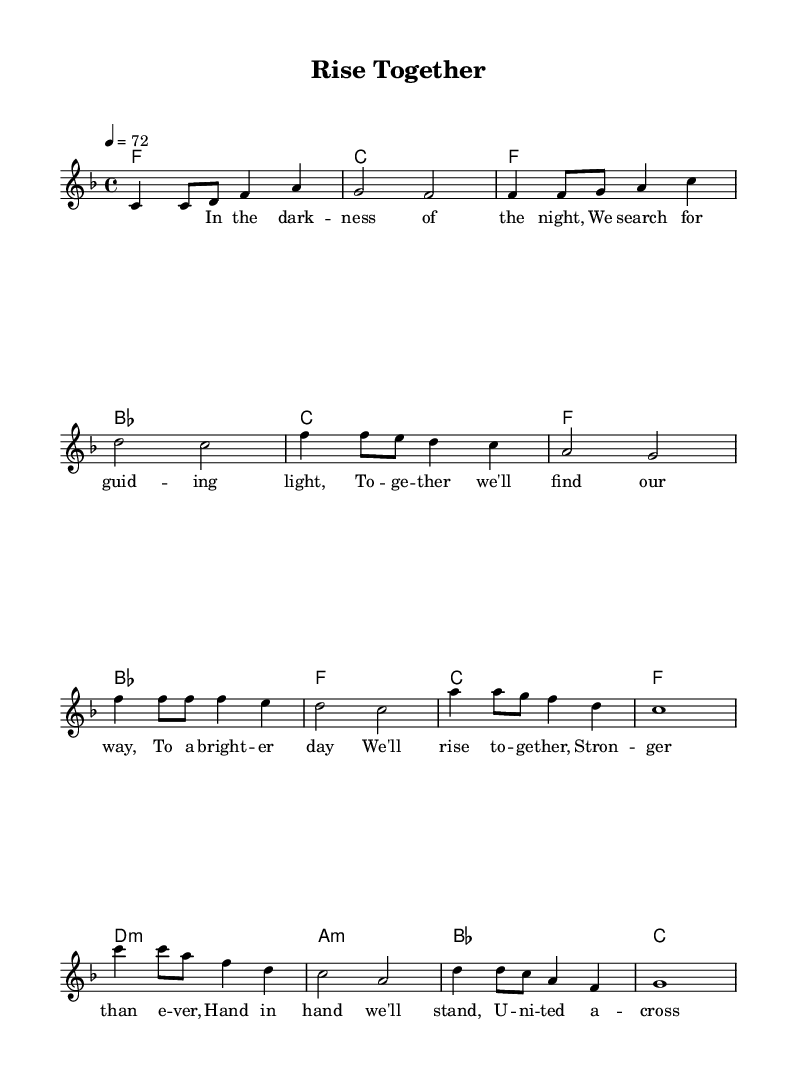What is the key signature of this music? The key signature is F major, which has one flat (B flat) indicated on the staff.
Answer: F major What is the time signature of the piece? The time signature shown is 4/4, which means there are four beats in a measure, and each quarter note gets one beat.
Answer: 4/4 What is the tempo marking of the composition? The tempo marking indicates a speed of 72 beats per minute, shown in the score near the beginning.
Answer: 72 How many sections are there in the piece? The piece consists of an intro, verse, chorus, and bridge, totaling four distinct sections.
Answer: Four What is the primary message conveyed in the lyrics? The lyrics emphasize unity and hope, calling for togetherness to build a better future despite challenges.
Answer: Unity and hope How does the chord progression in the chorus compare to the verse? The chords in the chorus have more emphasis on the B flat major and F major compared to the verse, enhancing its more impactful emotional delivery.
Answer: More emphasis on B flat major and F major Which musical elements enhance the soulful R&B character of the piece? The use of powerful vocal melodies and expressive lyrics centered on hope and connection, as well as a call-and-response feel, are key elements of the soulful R&B genre.
Answer: Powerful vocals and expressive lyrics 